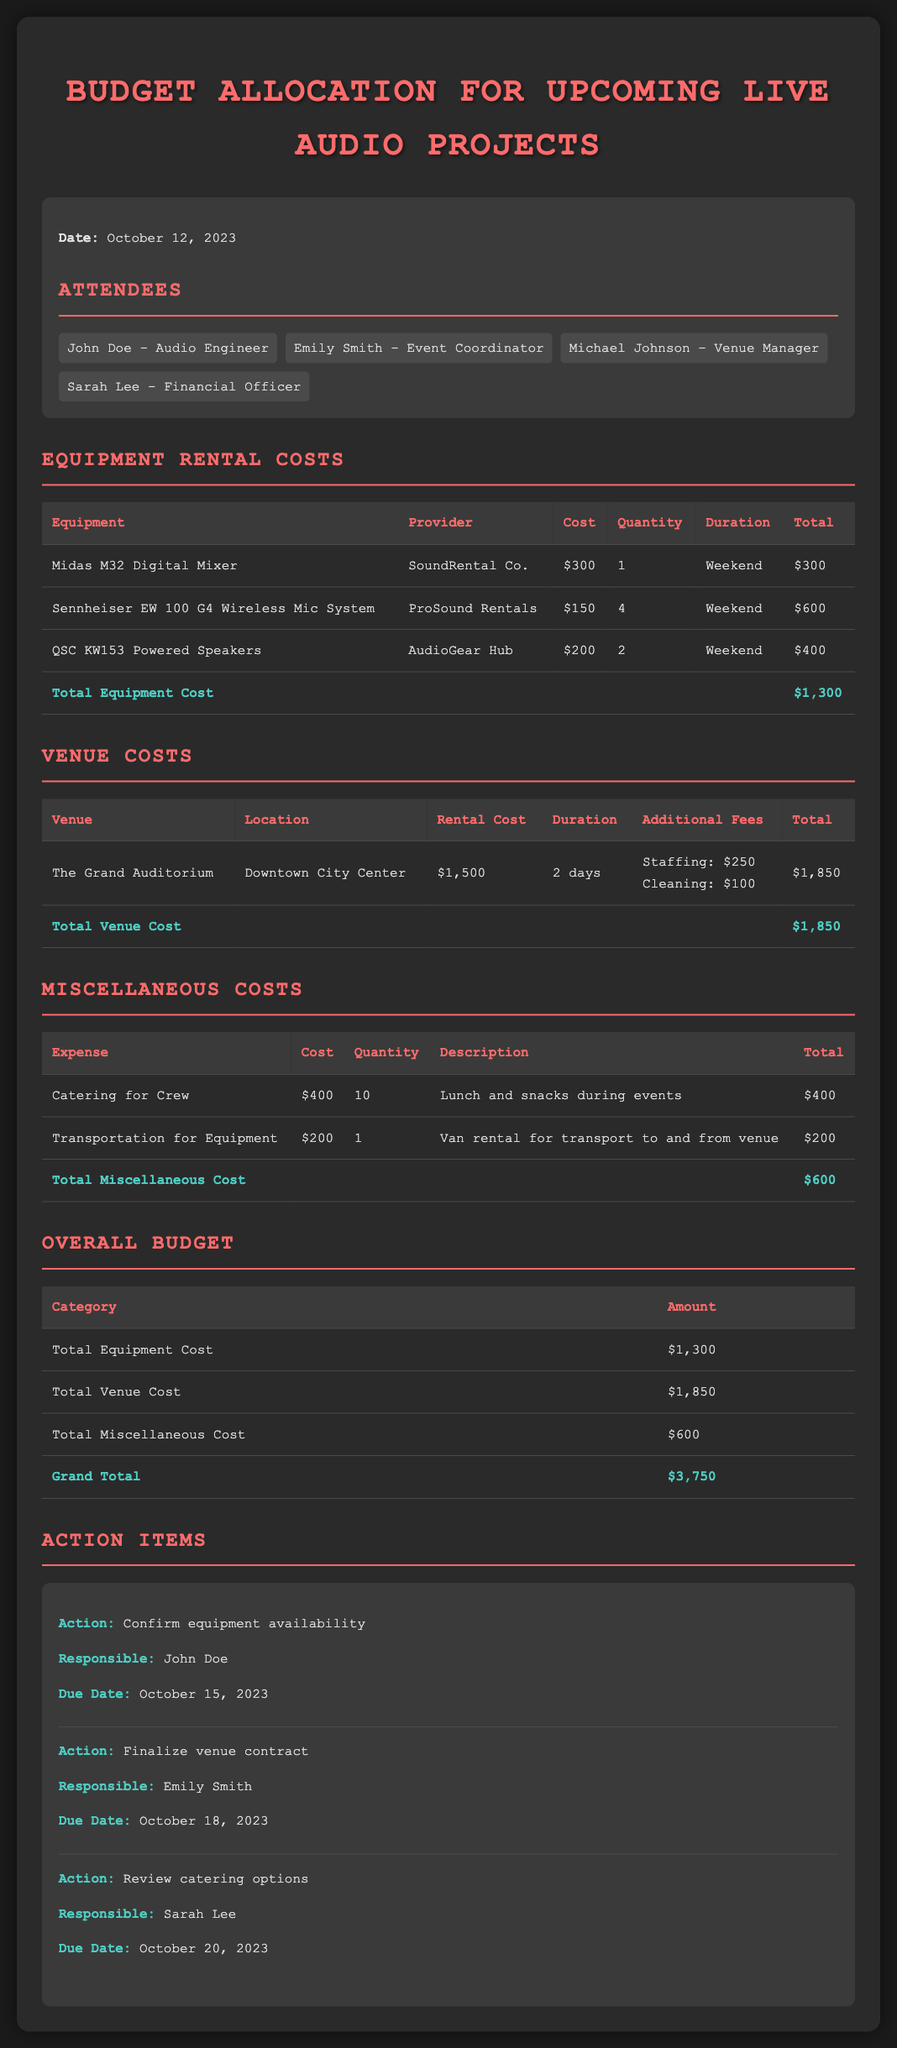What is the date of the meeting? The date of the meeting is stated at the start of the document.
Answer: October 12, 2023 Who is responsible for confirming equipment availability? The person responsible for confirming equipment availability is listed in the action items section.
Answer: John Doe What is the rental cost of The Grand Auditorium? The rental cost is detailed in the venue costs table.
Answer: $1,500 How many Sennheiser EW 100 G4 Wireless Mic Systems are rented? The quantity of this equipment is specified in the equipment rental costs section.
Answer: 4 What is the grand total for the overall budget? The grand total is calculated as the sum of all category totals in the overall budget table.
Answer: $3,750 What is the total cost for miscellaneous items? The total cost for miscellaneous items is provided in the miscellaneous costs section.
Answer: $600 When is the due date for finalizing the venue contract? The due date is mentioned under action items.
Answer: October 18, 2023 What additional fee is associated with the venue rental? Additional fees are listed in the venue costs section.
Answer: Staffing: $250, Cleaning: $100 What equipment is provided by SoundRental Co.? The equipment provided by this provider is specified in the equipment rental costs table.
Answer: Midas M32 Digital Mixer 